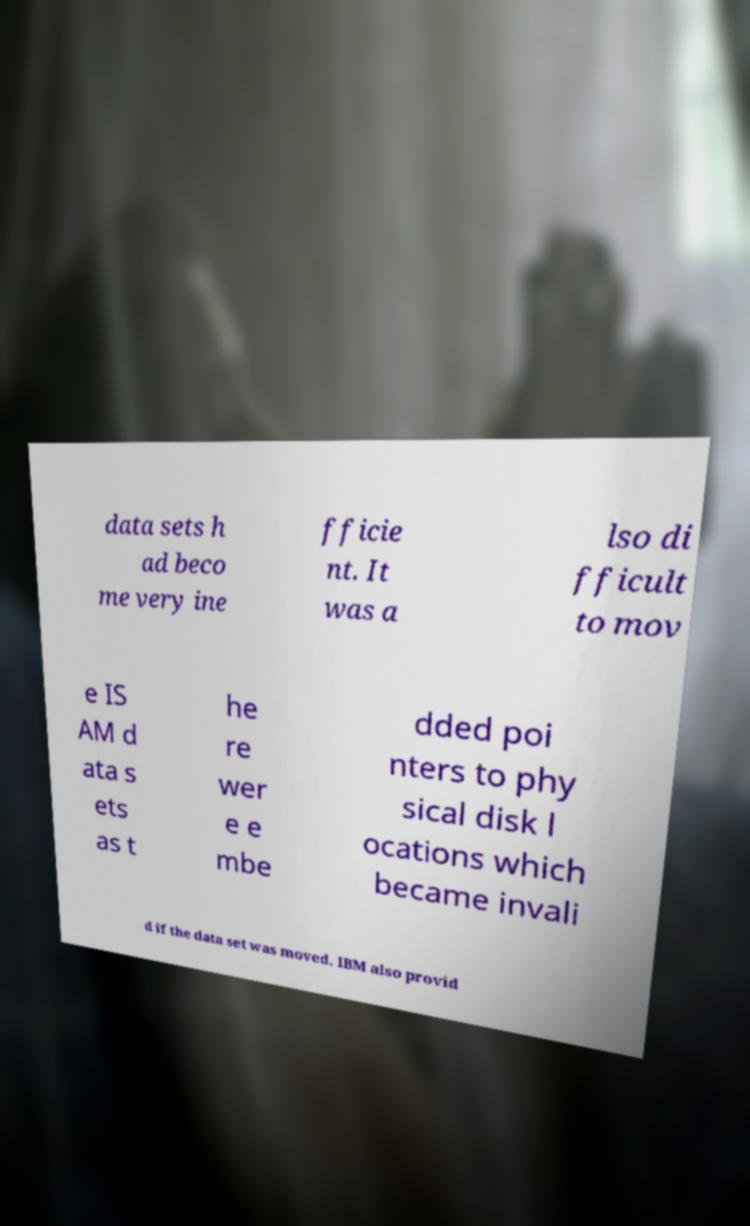For documentation purposes, I need the text within this image transcribed. Could you provide that? data sets h ad beco me very ine fficie nt. It was a lso di fficult to mov e IS AM d ata s ets as t he re wer e e mbe dded poi nters to phy sical disk l ocations which became invali d if the data set was moved. IBM also provid 